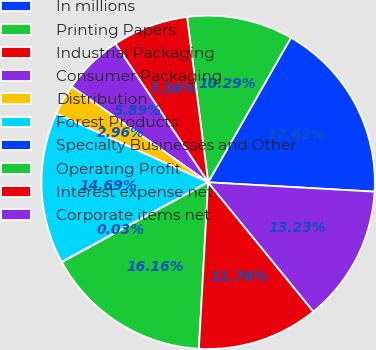Convert chart to OTSL. <chart><loc_0><loc_0><loc_500><loc_500><pie_chart><fcel>In millions<fcel>Printing Papers<fcel>Industrial Packaging<fcel>Consumer Packaging<fcel>Distribution<fcel>Forest Products<fcel>Specialty Businesses and Other<fcel>Operating Profit<fcel>Interest expense net<fcel>Corporate items net<nl><fcel>17.62%<fcel>10.29%<fcel>7.36%<fcel>5.89%<fcel>2.96%<fcel>14.69%<fcel>0.03%<fcel>16.16%<fcel>11.76%<fcel>13.23%<nl></chart> 